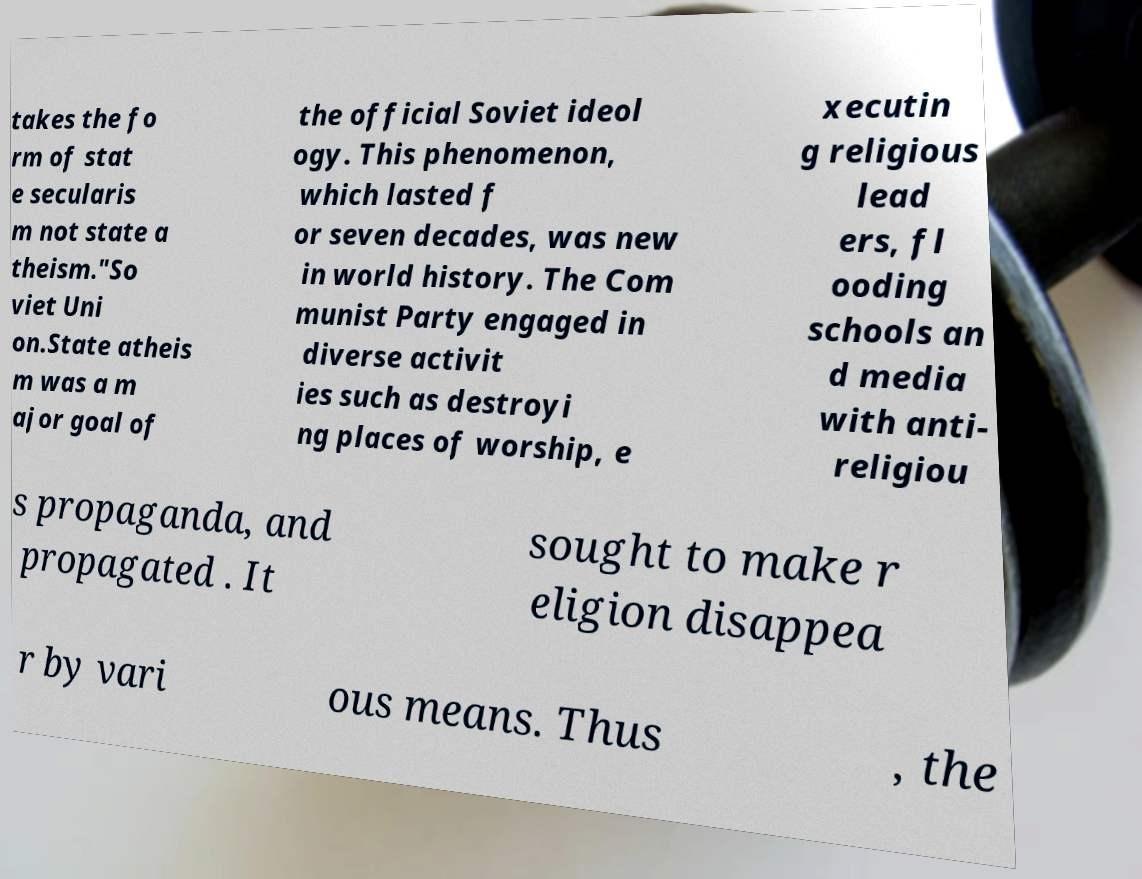Can you read and provide the text displayed in the image?This photo seems to have some interesting text. Can you extract and type it out for me? takes the fo rm of stat e secularis m not state a theism."So viet Uni on.State atheis m was a m ajor goal of the official Soviet ideol ogy. This phenomenon, which lasted f or seven decades, was new in world history. The Com munist Party engaged in diverse activit ies such as destroyi ng places of worship, e xecutin g religious lead ers, fl ooding schools an d media with anti- religiou s propaganda, and propagated . It sought to make r eligion disappea r by vari ous means. Thus , the 